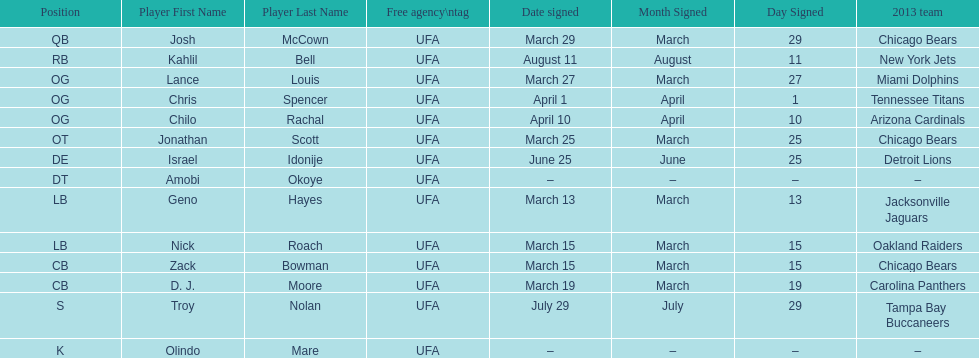The only player to sign in july? Troy Nolan. 